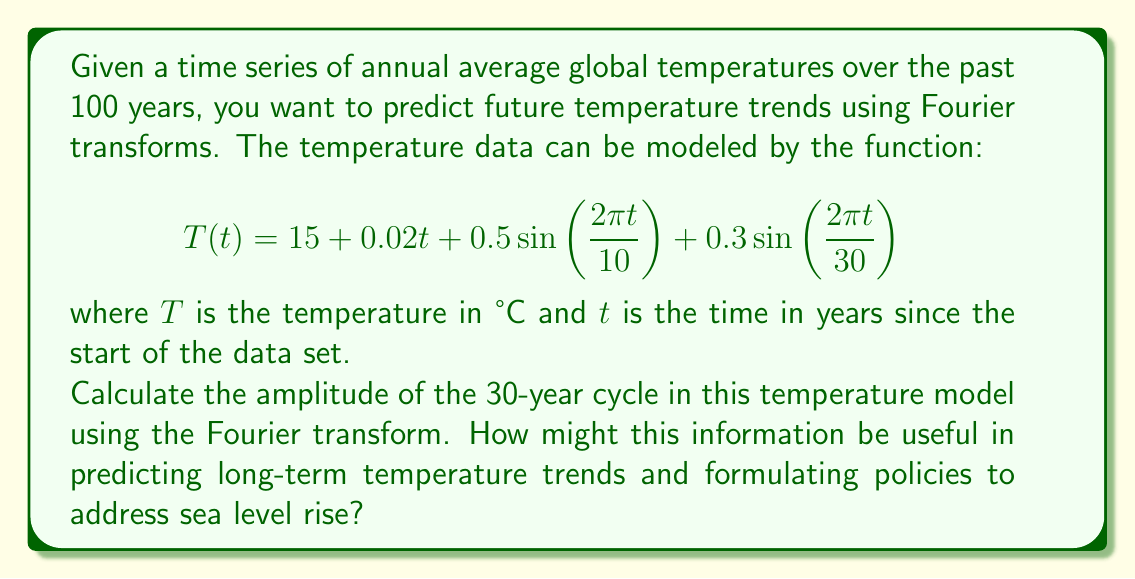Help me with this question. To solve this problem, we need to understand the Fourier transform and how it applies to our temperature model. The Fourier transform decomposes a function into its constituent frequencies, allowing us to identify periodic components in the data.

1) First, let's identify the components of our temperature model:
   - Constant term: 15°C (base temperature)
   - Linear trend: $0.02t$ (overall warming trend)
   - 10-year cycle: $0.5\sin(\frac{2\pi t}{10})$
   - 30-year cycle: $0.3\sin(\frac{2\pi t}{30})$

2) The Fourier transform will help us isolate these periodic components. In this case, we're specifically interested in the 30-year cycle.

3) For a sinusoidal function of the form $A\sin(\omega t)$, the amplitude $A$ corresponds to half the peak-to-peak variation in the Fourier transform.

4) In our model, the 30-year cycle is represented by:

   $$0.3\sin(\frac{2\pi t}{30})$$

5) Comparing this to the general form $A\sin(\omega t)$, we can see that the amplitude $A$ is 0.3°C.

This amplitude of 0.3°C for the 30-year cycle provides valuable information for predicting long-term temperature trends:

a) It indicates a significant multi-decadal oscillation in global temperatures.
b) This cycle could potentially mask or amplify the overall warming trend at different points in time.
c) Understanding this cycle can help in distinguishing between natural variability and anthropogenic climate change.
d) For policy-making related to sea level rise:
   - It emphasizes the need for long-term planning (beyond 30 years) to account for both the cycle and the overall trend.
   - It suggests that sea level rise mitigation strategies should be adaptable to account for these long-term fluctuations.
   - It highlights the importance of continuous monitoring to separate cyclic variations from the long-term warming trend.
Answer: The amplitude of the 30-year cycle in the temperature model is 0.3°C. 